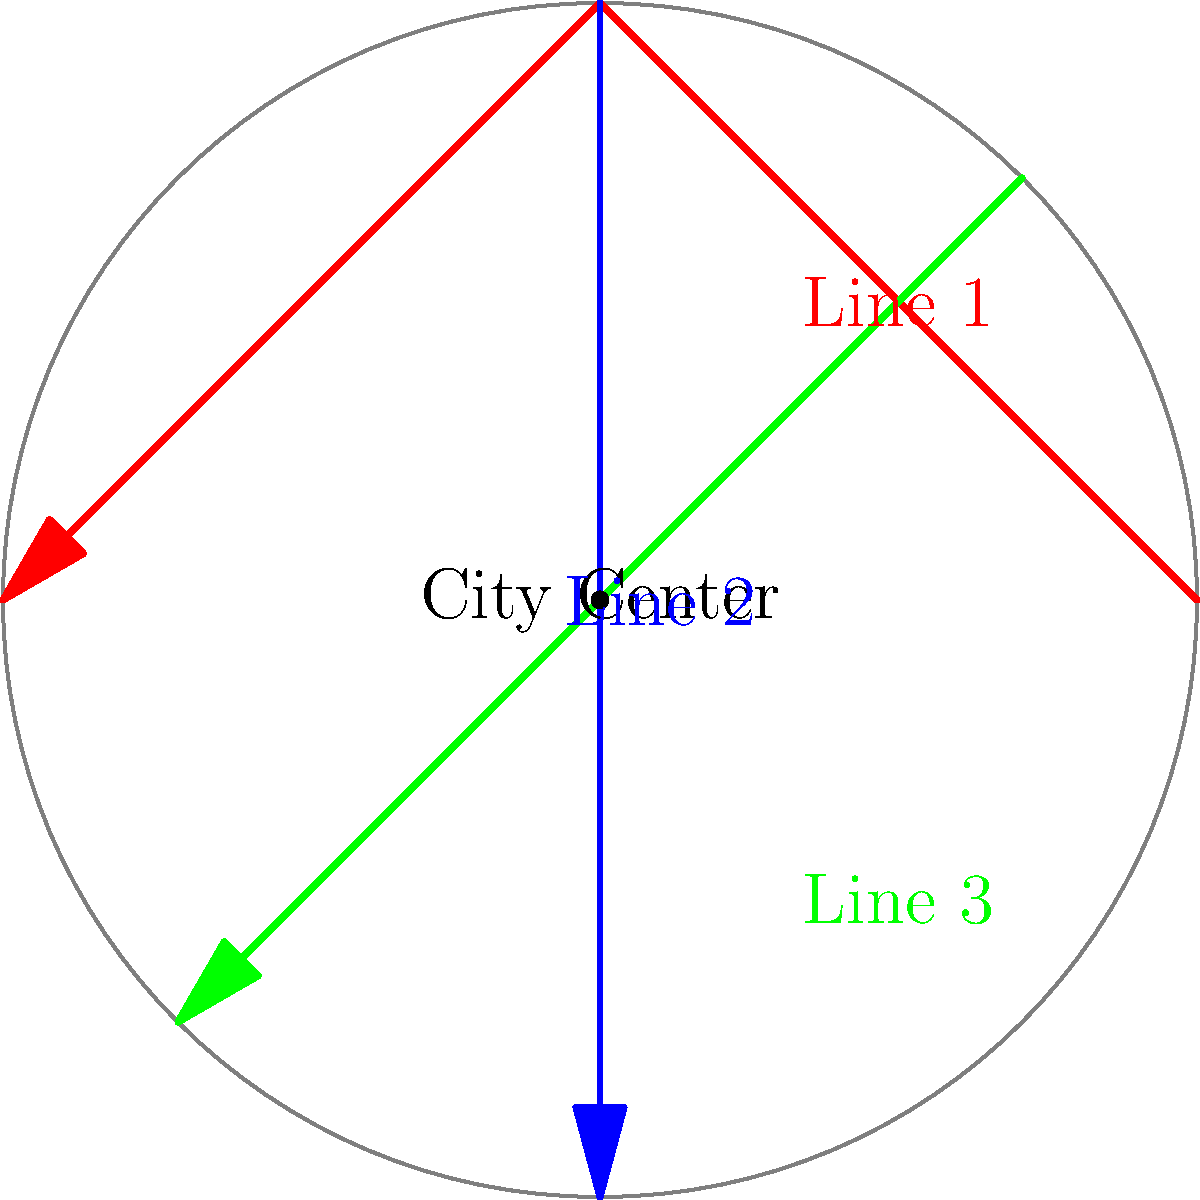As a senior executive in the transportation company, you are tasked with analyzing the impact of different subway line configurations on reducing traffic congestion. The diagram shows three proposed subway lines in a circular city. Which configuration would likely be most effective in reducing overall traffic congestion, and why?

a) Line 1 (red)
b) Line 2 (blue)
c) Line 3 (green)
d) A combination of Lines 1 and 2 To analyze the impact of different subway line configurations on reducing traffic congestion, we need to consider several factors:

1. Coverage: The extent to which the lines cover different areas of the city.
2. Directness: How directly the lines connect different parts of the city.
3. Intersections: The number of transfer points between lines.
4. City center access: How well the lines serve the city center.

Let's evaluate each option:

a) Line 1 (red): 
   - Covers three sides of the city
   - Provides direct connections between these areas
   - Passes through the city center

b) Line 2 (blue):
   - Runs straight through the city center
   - Connects north and south directly
   - Limited coverage of east and west areas

c) Line 3 (green):
   - Connects northeast to southwest
   - Passes near the city center
   - Limited coverage compared to other options

d) Combination of Lines 1 and 2:
   - Provides the most comprehensive coverage
   - Creates a "cross" shape, serving all four quadrants of the city
   - Offers two intersecting points for transfers
   - Both lines pass through the city center
   - Allows for easy access to the center from all directions

The combination of Lines 1 and 2 (option d) would likely be most effective in reducing overall traffic congestion because:

1. It provides the best coverage of the city, serving all quadrants.
2. It offers direct routes to and from the city center from multiple directions.
3. The intersection of the two lines allows for efficient transfers between different parts of the city.
4. This configuration would likely attract the most commuters, thereby reducing the number of private vehicles on the roads.

From a negotiation standpoint with union representatives, this option also provides the most job opportunities for subway workers while maximizing the public transport system's efficiency.
Answer: Combination of Lines 1 and 2 